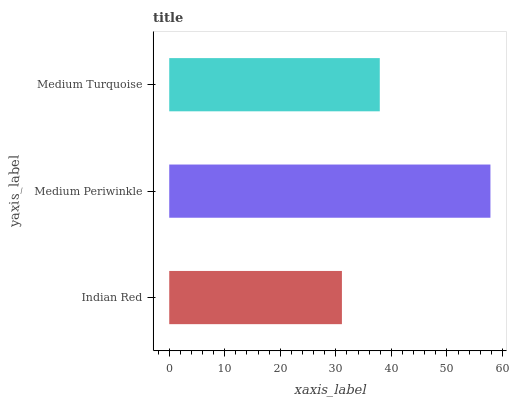Is Indian Red the minimum?
Answer yes or no. Yes. Is Medium Periwinkle the maximum?
Answer yes or no. Yes. Is Medium Turquoise the minimum?
Answer yes or no. No. Is Medium Turquoise the maximum?
Answer yes or no. No. Is Medium Periwinkle greater than Medium Turquoise?
Answer yes or no. Yes. Is Medium Turquoise less than Medium Periwinkle?
Answer yes or no. Yes. Is Medium Turquoise greater than Medium Periwinkle?
Answer yes or no. No. Is Medium Periwinkle less than Medium Turquoise?
Answer yes or no. No. Is Medium Turquoise the high median?
Answer yes or no. Yes. Is Medium Turquoise the low median?
Answer yes or no. Yes. Is Medium Periwinkle the high median?
Answer yes or no. No. Is Medium Periwinkle the low median?
Answer yes or no. No. 